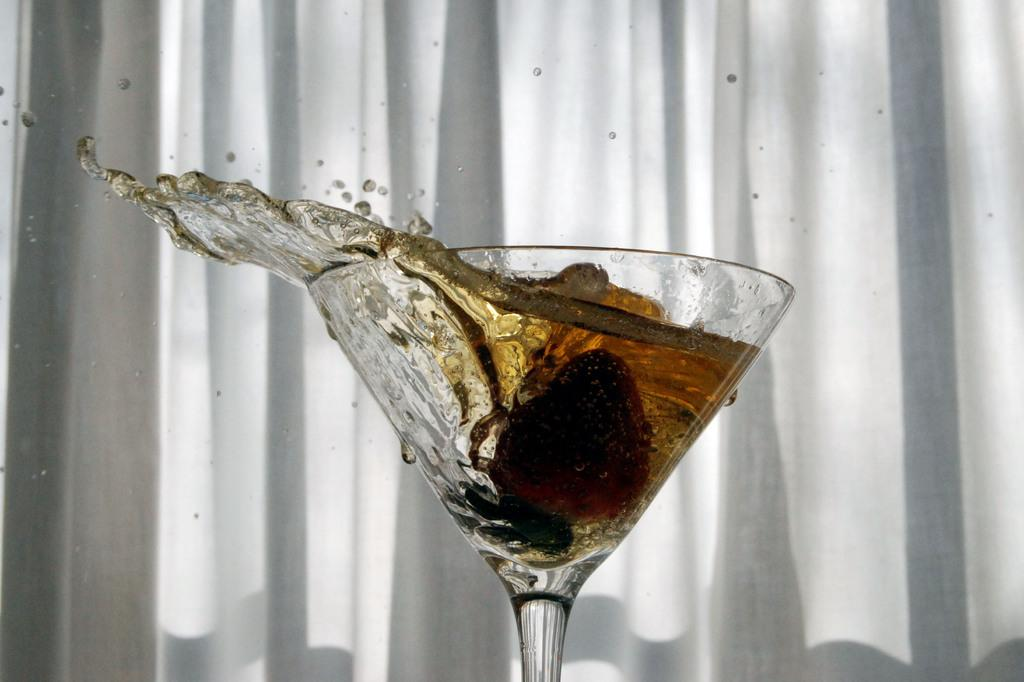What is in the glass that is visible in the image? There is liquid in the wine glass in the image. What type of glass is being used for the liquid? It is a wine glass. What can be seen in the background of the image? There is a white curtain in the background of the image. What type of chair is visible in the image? There is no chair present in the image. What material is the marble made of in the image? There is no marble present in the image. 